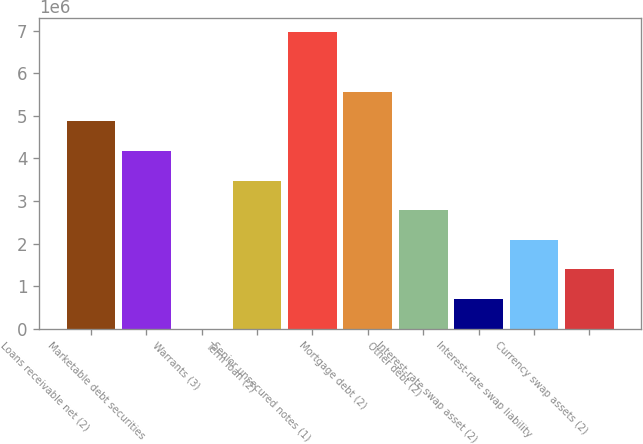Convert chart. <chart><loc_0><loc_0><loc_500><loc_500><bar_chart><fcel>Loans receivable net (2)<fcel>Marketable debt securities<fcel>Warrants (3)<fcel>Term loan (2)<fcel>Senior unsecured notes (1)<fcel>Mortgage debt (2)<fcel>Other debt (2)<fcel>Interest-rate swap asset (2)<fcel>Interest-rate swap liability<fcel>Currency swap assets (2)<nl><fcel>4.8744e+06<fcel>4.17807e+06<fcel>114<fcel>3.48174e+06<fcel>6.96338e+06<fcel>5.57072e+06<fcel>2.78542e+06<fcel>696440<fcel>2.08909e+06<fcel>1.39277e+06<nl></chart> 